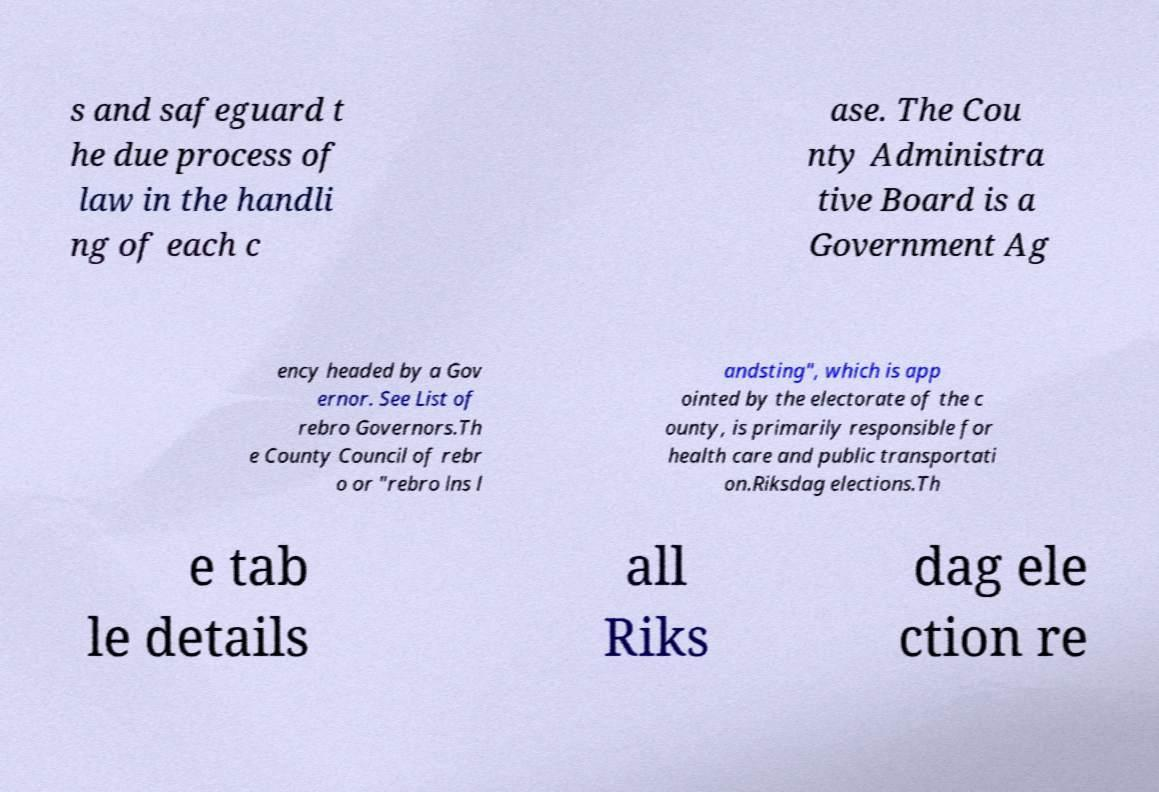Can you accurately transcribe the text from the provided image for me? s and safeguard t he due process of law in the handli ng of each c ase. The Cou nty Administra tive Board is a Government Ag ency headed by a Gov ernor. See List of rebro Governors.Th e County Council of rebr o or "rebro lns l andsting", which is app ointed by the electorate of the c ounty, is primarily responsible for health care and public transportati on.Riksdag elections.Th e tab le details all Riks dag ele ction re 